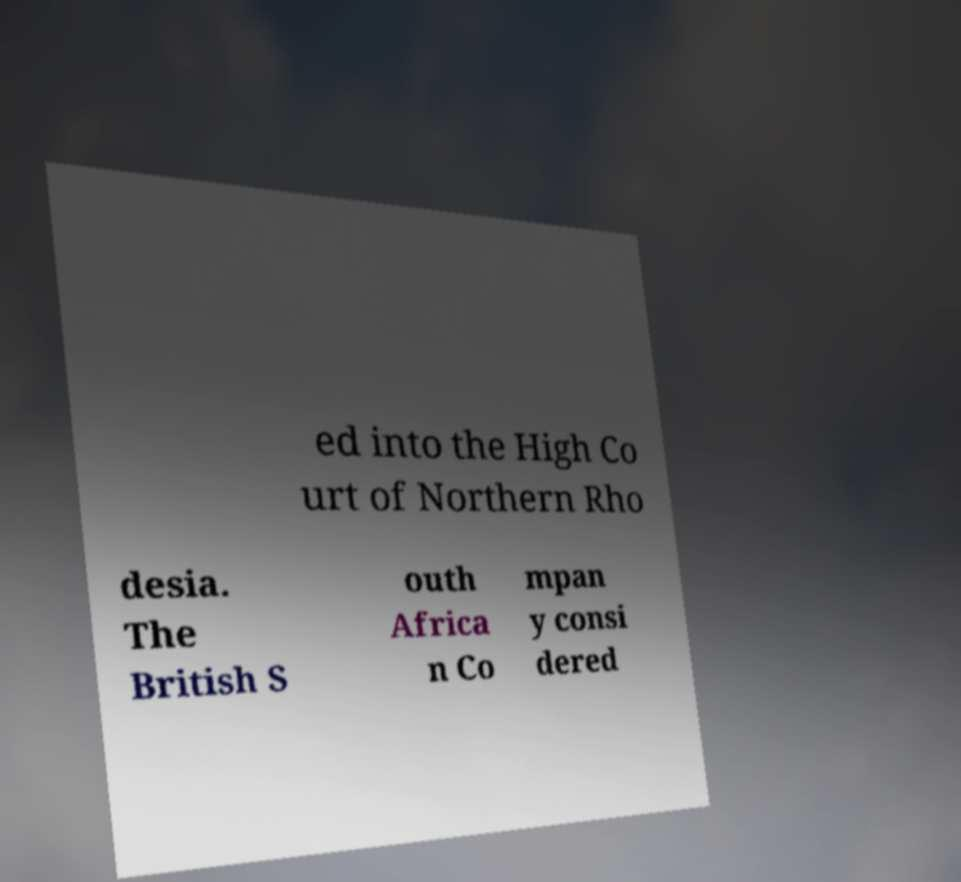Could you extract and type out the text from this image? ed into the High Co urt of Northern Rho desia. The British S outh Africa n Co mpan y consi dered 